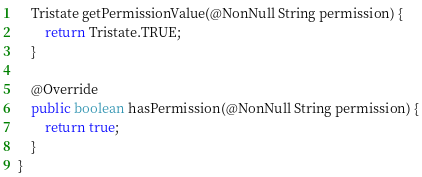Convert code to text. <code><loc_0><loc_0><loc_500><loc_500><_Java_>    Tristate getPermissionValue(@NonNull String permission) {
        return Tristate.TRUE;
    }
    
    @Override
    public boolean hasPermission(@NonNull String permission) {
        return true;
    }
}</code> 